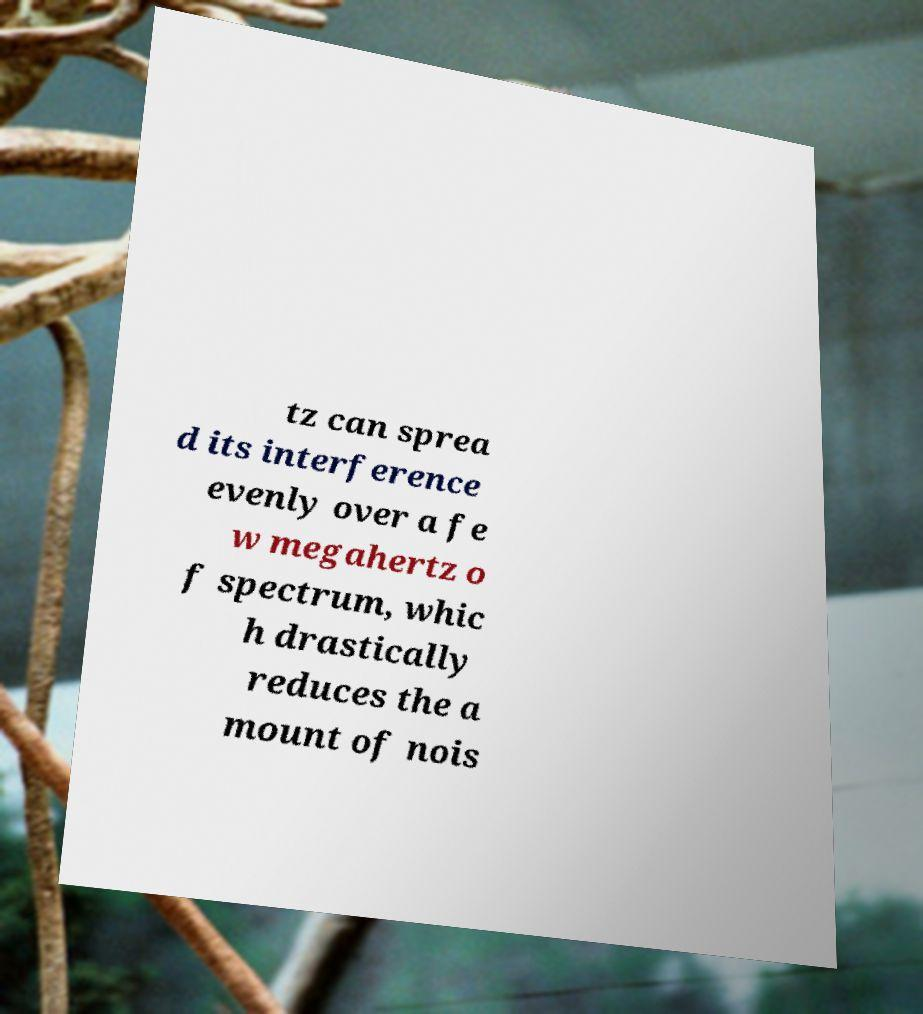Can you read and provide the text displayed in the image?This photo seems to have some interesting text. Can you extract and type it out for me? tz can sprea d its interference evenly over a fe w megahertz o f spectrum, whic h drastically reduces the a mount of nois 